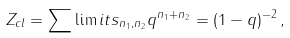Convert formula to latex. <formula><loc_0><loc_0><loc_500><loc_500>Z _ { c l } = \sum \lim i t s _ { n _ { 1 } , n _ { 2 } } { q ^ { n _ { 1 } + n _ { 2 } } = ( 1 - q ) ^ { - 2 } } \, ,</formula> 